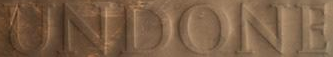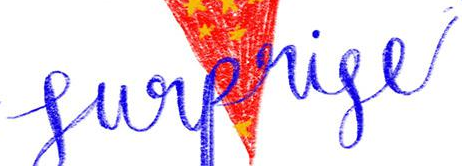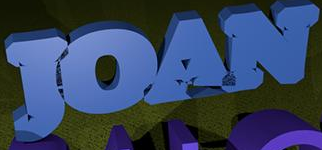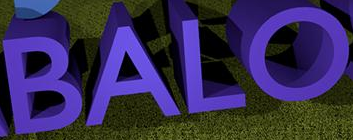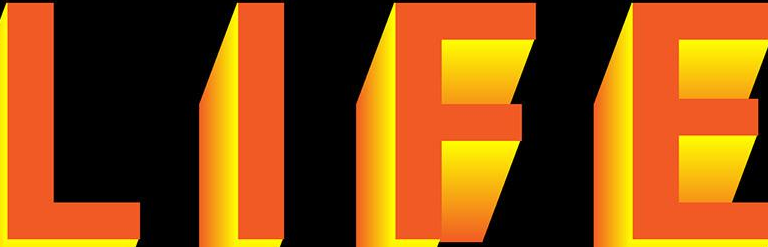Read the text from these images in sequence, separated by a semicolon. UNDONE; Surprise; JOAN; BALO; LIFE 